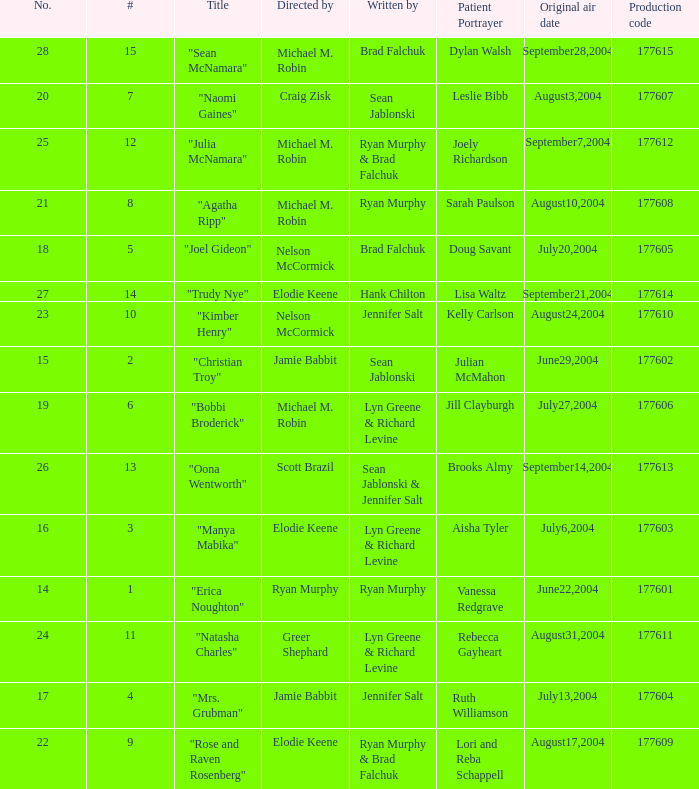Who directed the episode with production code 177605? Nelson McCormick. 